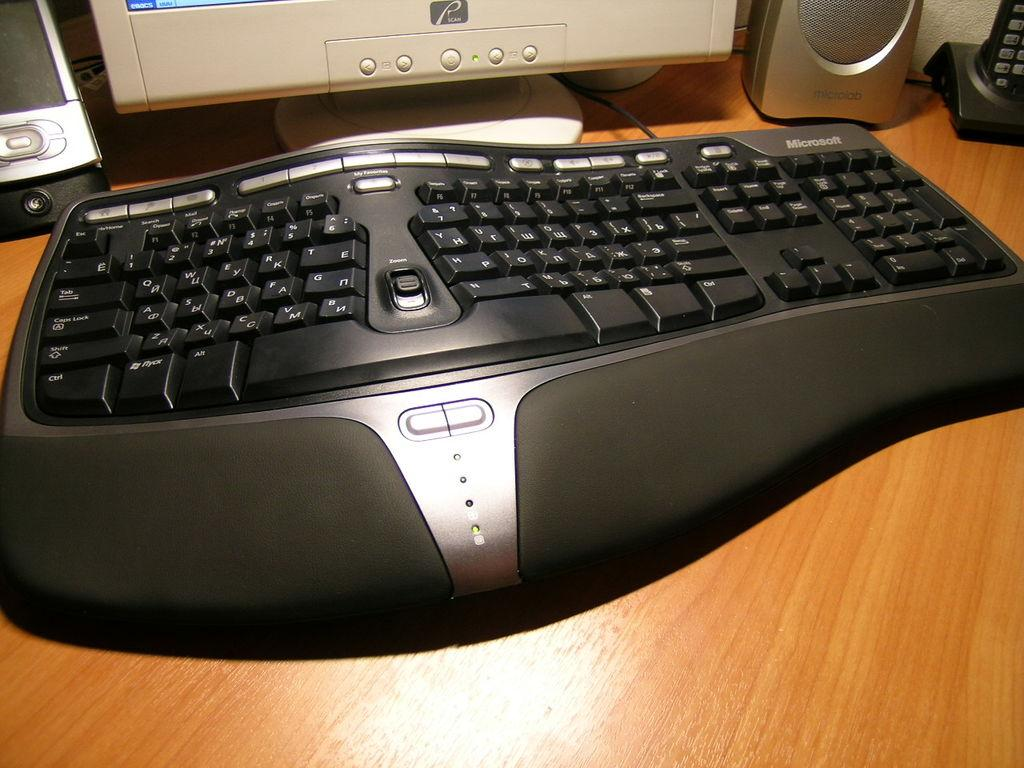<image>
Relay a brief, clear account of the picture shown. A split computer keyboard is in front of a monitor with a "scan" sticker. 